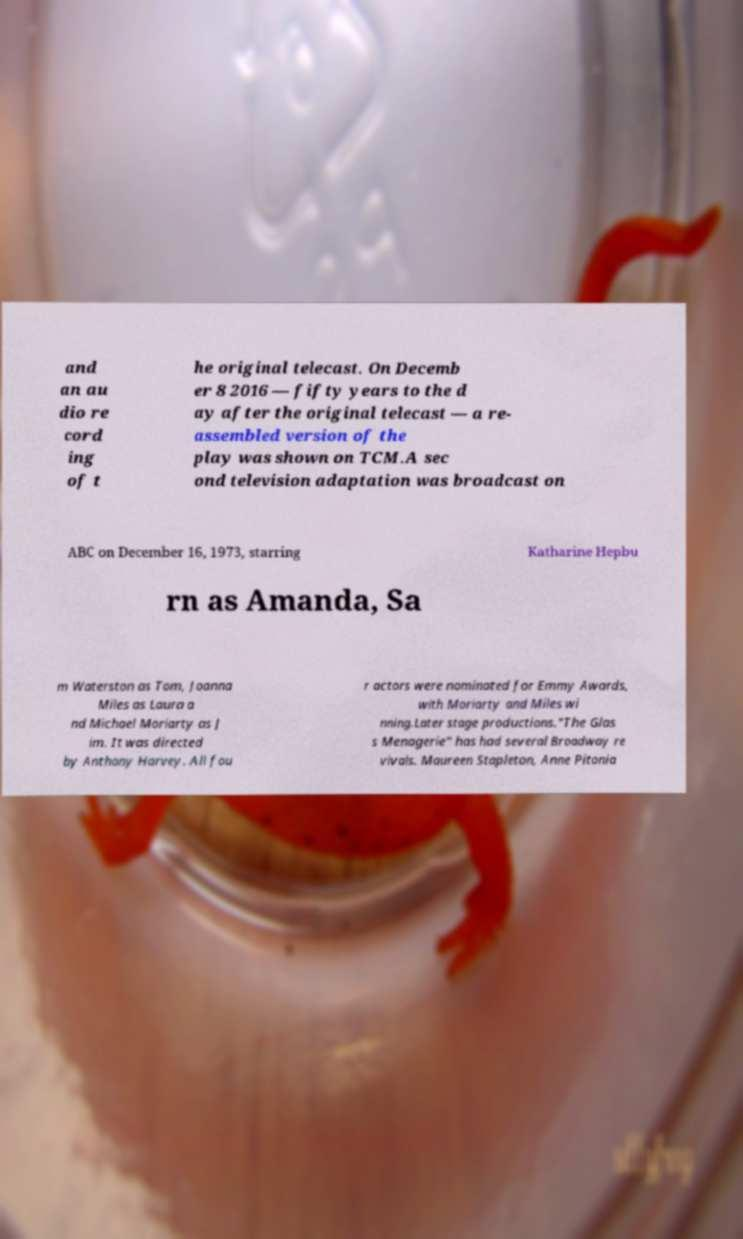Could you assist in decoding the text presented in this image and type it out clearly? and an au dio re cord ing of t he original telecast. On Decemb er 8 2016 — fifty years to the d ay after the original telecast — a re- assembled version of the play was shown on TCM.A sec ond television adaptation was broadcast on ABC on December 16, 1973, starring Katharine Hepbu rn as Amanda, Sa m Waterston as Tom, Joanna Miles as Laura a nd Michael Moriarty as J im. It was directed by Anthony Harvey. All fou r actors were nominated for Emmy Awards, with Moriarty and Miles wi nning.Later stage productions."The Glas s Menagerie" has had several Broadway re vivals. Maureen Stapleton, Anne Pitonia 